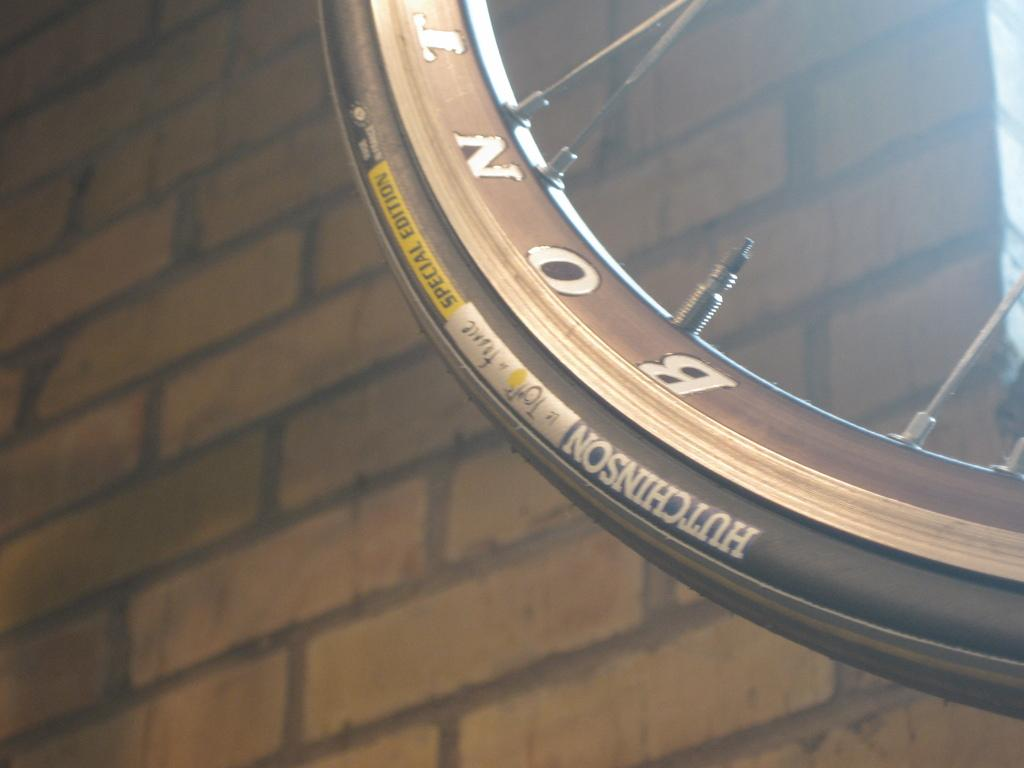What shape is the main object in the image? The main object in the image is a circular rim. What can be seen in the background of the image? There is a brick wall in the background of the image. What did the aunt say to the hall before leaving in the image? There is no mention of an aunt, a hall, or any dialogue in the image. 